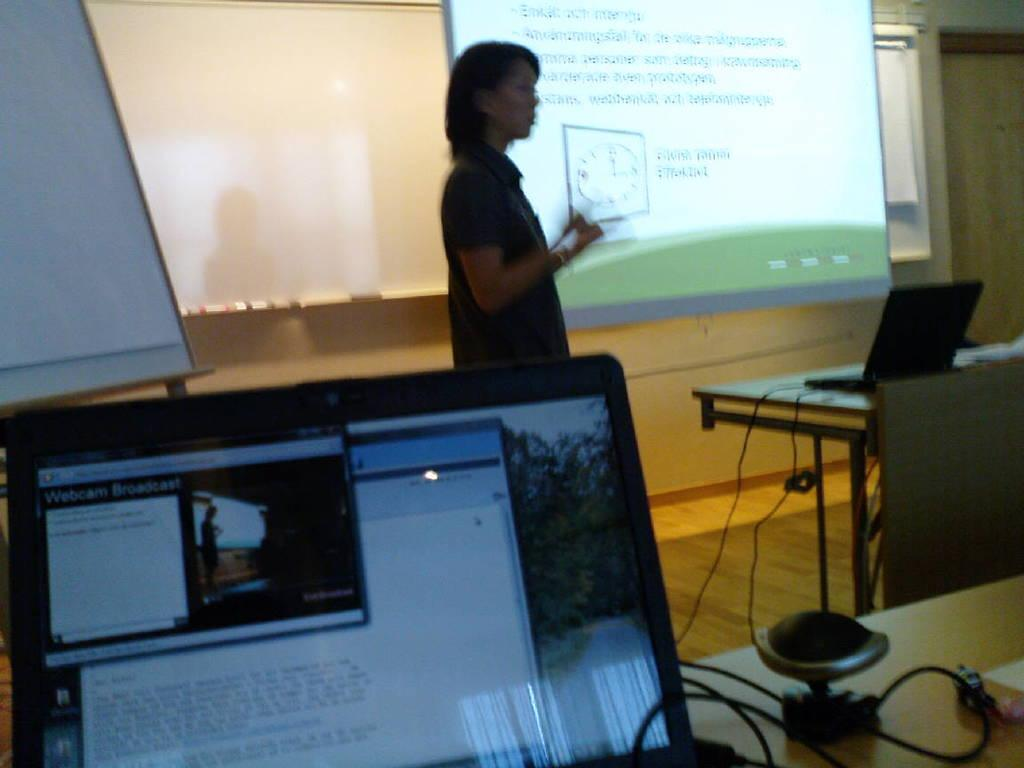What is the primary subject in the image? There is a woman standing in the image. Where is the woman standing? The woman is standing on the floor. What can be seen on the table in the image? There are laptops on the table. What is visible in the background of the image? There is a screen visible in the background of the image. What type of chess pieces can be seen on the table in the image? There are no chess pieces present in the image; it features a woman standing, a table with laptops, and a screen in the background. What color is the orange on the table in the image? There is no orange present on the table in the image. 